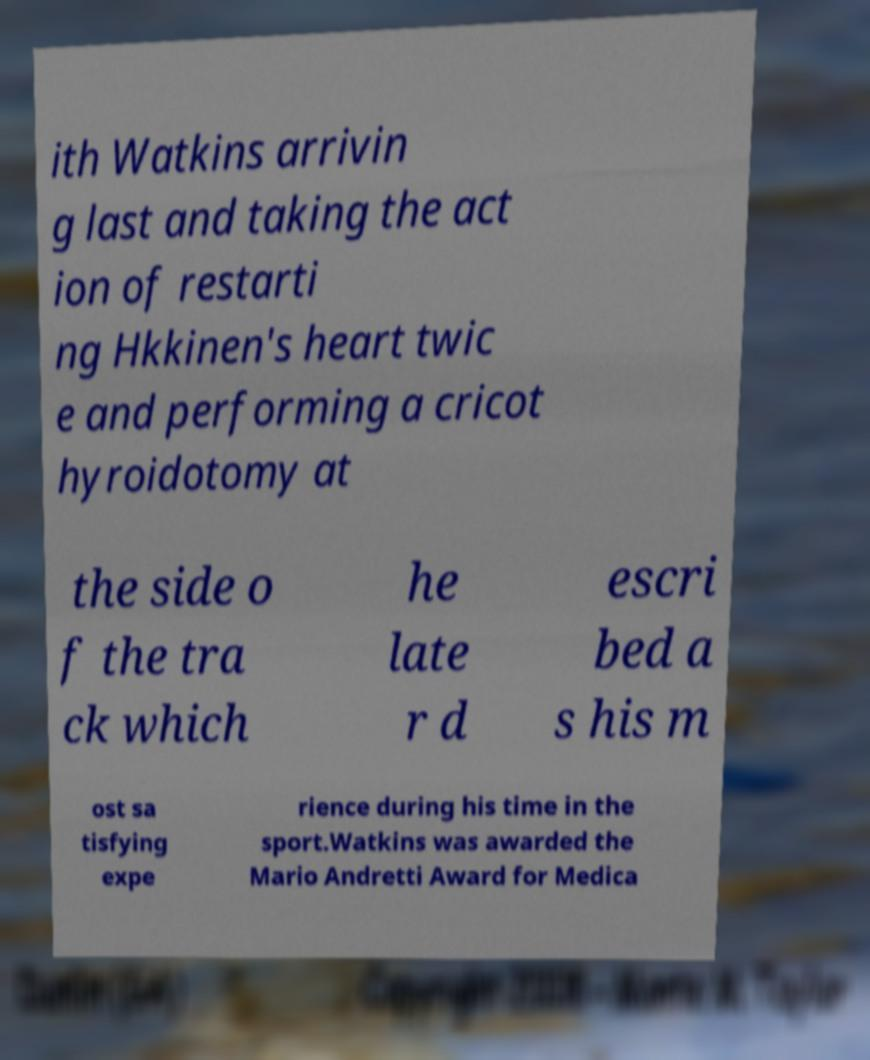There's text embedded in this image that I need extracted. Can you transcribe it verbatim? ith Watkins arrivin g last and taking the act ion of restarti ng Hkkinen's heart twic e and performing a cricot hyroidotomy at the side o f the tra ck which he late r d escri bed a s his m ost sa tisfying expe rience during his time in the sport.Watkins was awarded the Mario Andretti Award for Medica 